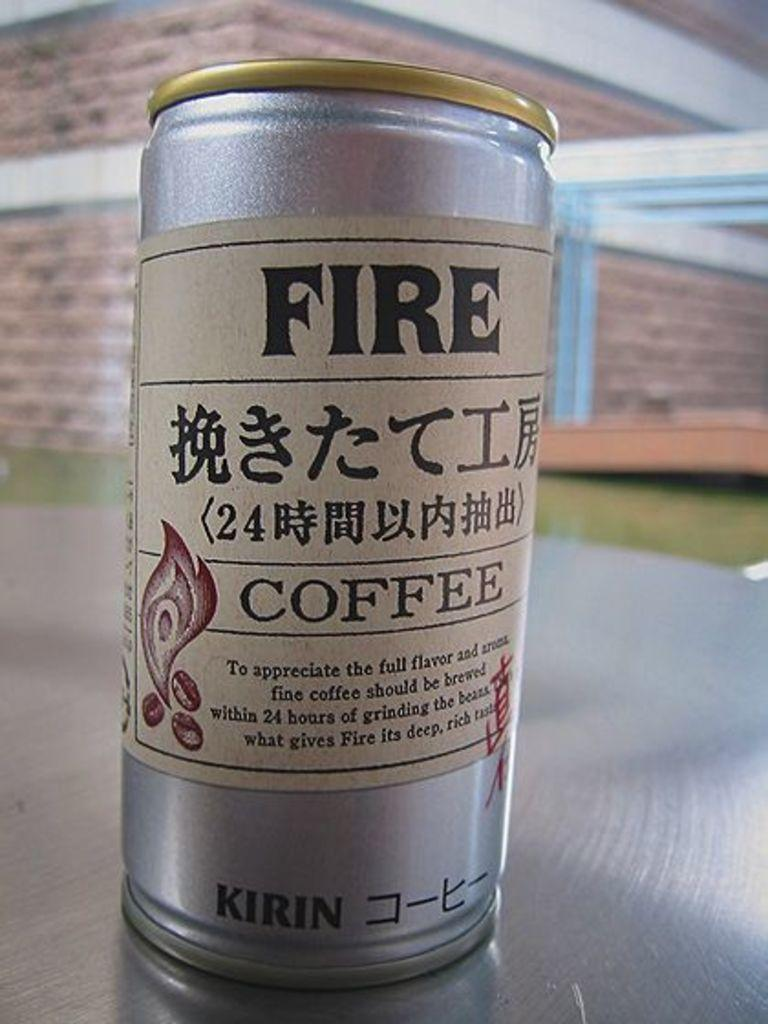<image>
Describe the image concisely. A can of Kirin brand Fire coffee with foreign lettering all over it. 